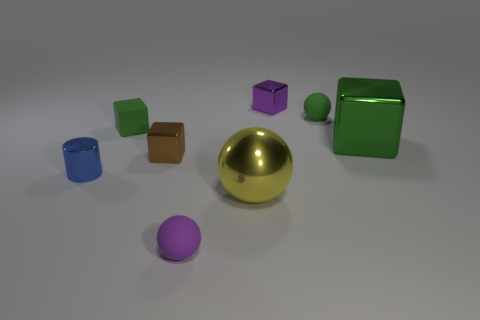Subtract all tiny blocks. How many blocks are left? 1 Add 1 small purple matte balls. How many objects exist? 9 Subtract all yellow spheres. How many spheres are left? 2 Subtract 1 purple cubes. How many objects are left? 7 Subtract all balls. How many objects are left? 5 Subtract 1 spheres. How many spheres are left? 2 Subtract all purple spheres. Subtract all gray cylinders. How many spheres are left? 2 Subtract all gray balls. How many brown blocks are left? 1 Subtract all small brown shiny things. Subtract all blocks. How many objects are left? 3 Add 6 small green matte blocks. How many small green matte blocks are left? 7 